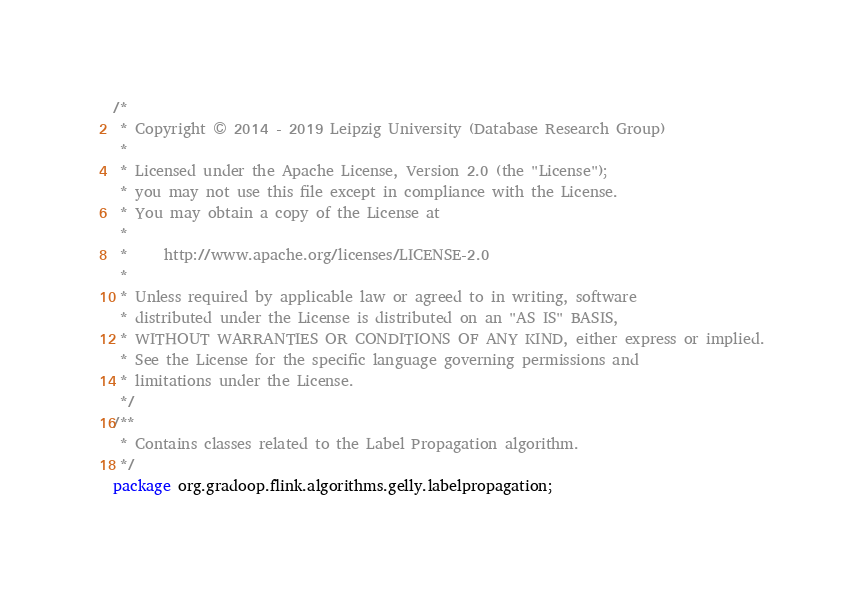<code> <loc_0><loc_0><loc_500><loc_500><_Java_>/*
 * Copyright © 2014 - 2019 Leipzig University (Database Research Group)
 *
 * Licensed under the Apache License, Version 2.0 (the "License");
 * you may not use this file except in compliance with the License.
 * You may obtain a copy of the License at
 *
 *     http://www.apache.org/licenses/LICENSE-2.0
 *
 * Unless required by applicable law or agreed to in writing, software
 * distributed under the License is distributed on an "AS IS" BASIS,
 * WITHOUT WARRANTIES OR CONDITIONS OF ANY KIND, either express or implied.
 * See the License for the specific language governing permissions and
 * limitations under the License.
 */
/**
 * Contains classes related to the Label Propagation algorithm.
 */
package org.gradoop.flink.algorithms.gelly.labelpropagation;
</code> 